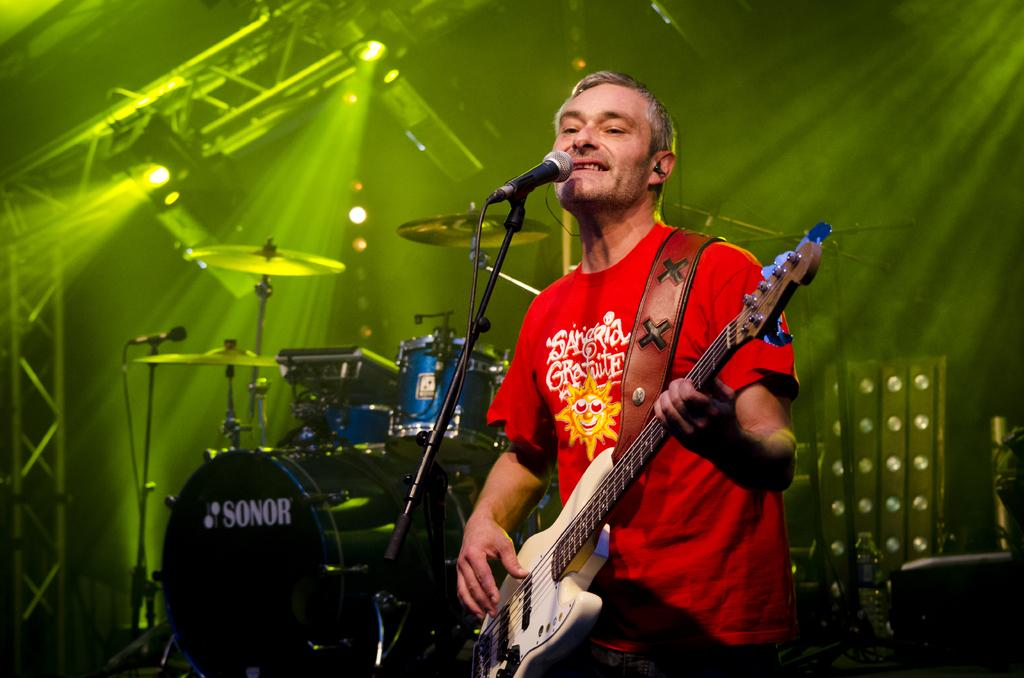What is the person in the image doing? The person is sitting and holding a guitar. What other musical instruments can be seen in the image? There are drum plates and drums in the image. What equipment is present for amplifying sound? There is a microphone with a stand in the image. What type of lighting is visible at the top of the image? There are focusing lights visible at the top of the image. What type of wall decoration can be seen in the image? There is no mention of any wall decoration in the provided facts, so it cannot be determined from the image. 